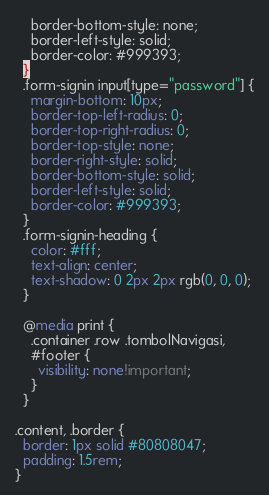<code> <loc_0><loc_0><loc_500><loc_500><_CSS_>    border-bottom-style: none;
    border-left-style: solid;
    border-color: #999393;
  }
  .form-signin input[type="password"] {
    margin-bottom: 10px;
    border-top-left-radius: 0;
    border-top-right-radius: 0;
    border-top-style: none;
    border-right-style: solid;
    border-bottom-style: solid;
    border-left-style: solid;
    border-color: #999393;
  }
  .form-signin-heading {
    color: #fff;
    text-align: center;
    text-shadow: 0 2px 2px rgb(0, 0, 0);
  }

  @media print {
    .container .row .tombolNavigasi,
    #footer {
      visibility: none!important;
    }
  }

.content, .border {
  border: 1px solid #80808047;
  padding: 1.5rem;
}</code> 